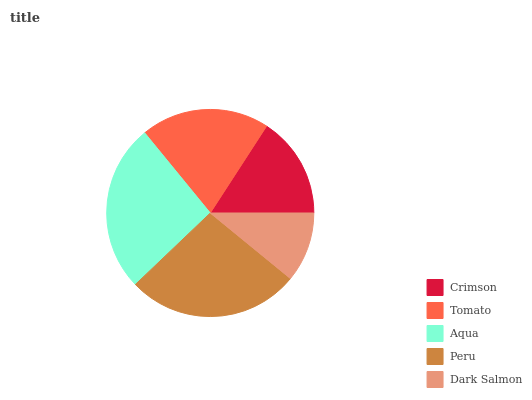Is Dark Salmon the minimum?
Answer yes or no. Yes. Is Peru the maximum?
Answer yes or no. Yes. Is Tomato the minimum?
Answer yes or no. No. Is Tomato the maximum?
Answer yes or no. No. Is Tomato greater than Crimson?
Answer yes or no. Yes. Is Crimson less than Tomato?
Answer yes or no. Yes. Is Crimson greater than Tomato?
Answer yes or no. No. Is Tomato less than Crimson?
Answer yes or no. No. Is Tomato the high median?
Answer yes or no. Yes. Is Tomato the low median?
Answer yes or no. Yes. Is Crimson the high median?
Answer yes or no. No. Is Crimson the low median?
Answer yes or no. No. 